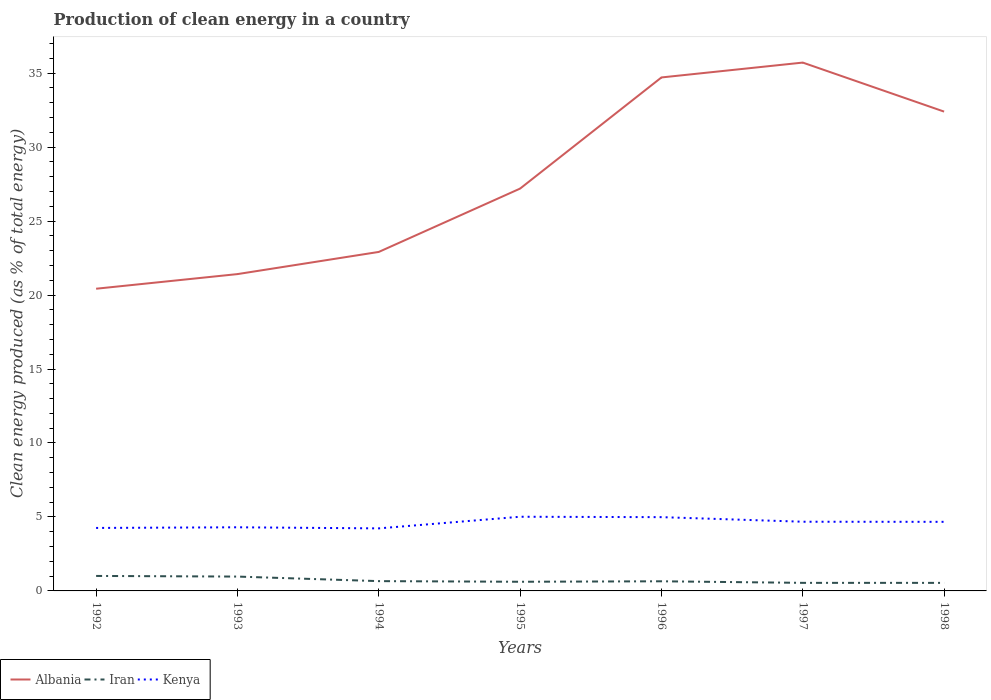Across all years, what is the maximum percentage of clean energy produced in Kenya?
Provide a succinct answer. 4.23. In which year was the percentage of clean energy produced in Iran maximum?
Offer a terse response. 1998. What is the total percentage of clean energy produced in Albania in the graph?
Your answer should be compact. -14.28. What is the difference between the highest and the second highest percentage of clean energy produced in Albania?
Provide a succinct answer. 15.29. What is the difference between the highest and the lowest percentage of clean energy produced in Kenya?
Keep it short and to the point. 4. Is the percentage of clean energy produced in Kenya strictly greater than the percentage of clean energy produced in Iran over the years?
Your response must be concise. No. How many lines are there?
Ensure brevity in your answer.  3. How many years are there in the graph?
Your answer should be very brief. 7. Does the graph contain grids?
Provide a succinct answer. No. How many legend labels are there?
Ensure brevity in your answer.  3. How are the legend labels stacked?
Your answer should be very brief. Horizontal. What is the title of the graph?
Provide a short and direct response. Production of clean energy in a country. What is the label or title of the Y-axis?
Give a very brief answer. Clean energy produced (as % of total energy). What is the Clean energy produced (as % of total energy) in Albania in 1992?
Provide a short and direct response. 20.43. What is the Clean energy produced (as % of total energy) of Iran in 1992?
Ensure brevity in your answer.  1.01. What is the Clean energy produced (as % of total energy) of Kenya in 1992?
Make the answer very short. 4.26. What is the Clean energy produced (as % of total energy) of Albania in 1993?
Your answer should be very brief. 21.41. What is the Clean energy produced (as % of total energy) in Iran in 1993?
Your answer should be very brief. 0.97. What is the Clean energy produced (as % of total energy) of Kenya in 1993?
Ensure brevity in your answer.  4.3. What is the Clean energy produced (as % of total energy) of Albania in 1994?
Your answer should be compact. 22.91. What is the Clean energy produced (as % of total energy) in Iran in 1994?
Your answer should be compact. 0.66. What is the Clean energy produced (as % of total energy) in Kenya in 1994?
Your response must be concise. 4.23. What is the Clean energy produced (as % of total energy) in Albania in 1995?
Give a very brief answer. 27.2. What is the Clean energy produced (as % of total energy) in Iran in 1995?
Ensure brevity in your answer.  0.62. What is the Clean energy produced (as % of total energy) in Kenya in 1995?
Offer a terse response. 5.01. What is the Clean energy produced (as % of total energy) of Albania in 1996?
Your answer should be compact. 34.71. What is the Clean energy produced (as % of total energy) in Iran in 1996?
Make the answer very short. 0.65. What is the Clean energy produced (as % of total energy) in Kenya in 1996?
Ensure brevity in your answer.  4.99. What is the Clean energy produced (as % of total energy) of Albania in 1997?
Give a very brief answer. 35.71. What is the Clean energy produced (as % of total energy) of Iran in 1997?
Offer a very short reply. 0.55. What is the Clean energy produced (as % of total energy) of Kenya in 1997?
Offer a terse response. 4.68. What is the Clean energy produced (as % of total energy) of Albania in 1998?
Ensure brevity in your answer.  32.4. What is the Clean energy produced (as % of total energy) of Iran in 1998?
Keep it short and to the point. 0.54. What is the Clean energy produced (as % of total energy) in Kenya in 1998?
Ensure brevity in your answer.  4.67. Across all years, what is the maximum Clean energy produced (as % of total energy) in Albania?
Ensure brevity in your answer.  35.71. Across all years, what is the maximum Clean energy produced (as % of total energy) of Iran?
Give a very brief answer. 1.01. Across all years, what is the maximum Clean energy produced (as % of total energy) of Kenya?
Your answer should be compact. 5.01. Across all years, what is the minimum Clean energy produced (as % of total energy) of Albania?
Make the answer very short. 20.43. Across all years, what is the minimum Clean energy produced (as % of total energy) of Iran?
Offer a terse response. 0.54. Across all years, what is the minimum Clean energy produced (as % of total energy) of Kenya?
Make the answer very short. 4.23. What is the total Clean energy produced (as % of total energy) in Albania in the graph?
Your answer should be compact. 194.77. What is the total Clean energy produced (as % of total energy) in Iran in the graph?
Give a very brief answer. 5. What is the total Clean energy produced (as % of total energy) in Kenya in the graph?
Ensure brevity in your answer.  32.13. What is the difference between the Clean energy produced (as % of total energy) in Albania in 1992 and that in 1993?
Provide a short and direct response. -0.99. What is the difference between the Clean energy produced (as % of total energy) of Iran in 1992 and that in 1993?
Provide a short and direct response. 0.04. What is the difference between the Clean energy produced (as % of total energy) of Kenya in 1992 and that in 1993?
Provide a succinct answer. -0.04. What is the difference between the Clean energy produced (as % of total energy) in Albania in 1992 and that in 1994?
Your answer should be compact. -2.49. What is the difference between the Clean energy produced (as % of total energy) in Iran in 1992 and that in 1994?
Ensure brevity in your answer.  0.35. What is the difference between the Clean energy produced (as % of total energy) of Kenya in 1992 and that in 1994?
Provide a short and direct response. 0.03. What is the difference between the Clean energy produced (as % of total energy) of Albania in 1992 and that in 1995?
Your answer should be very brief. -6.77. What is the difference between the Clean energy produced (as % of total energy) of Iran in 1992 and that in 1995?
Your response must be concise. 0.39. What is the difference between the Clean energy produced (as % of total energy) in Kenya in 1992 and that in 1995?
Provide a succinct answer. -0.76. What is the difference between the Clean energy produced (as % of total energy) of Albania in 1992 and that in 1996?
Provide a succinct answer. -14.28. What is the difference between the Clean energy produced (as % of total energy) of Iran in 1992 and that in 1996?
Ensure brevity in your answer.  0.36. What is the difference between the Clean energy produced (as % of total energy) of Kenya in 1992 and that in 1996?
Offer a very short reply. -0.73. What is the difference between the Clean energy produced (as % of total energy) of Albania in 1992 and that in 1997?
Offer a terse response. -15.29. What is the difference between the Clean energy produced (as % of total energy) in Iran in 1992 and that in 1997?
Ensure brevity in your answer.  0.47. What is the difference between the Clean energy produced (as % of total energy) of Kenya in 1992 and that in 1997?
Offer a very short reply. -0.42. What is the difference between the Clean energy produced (as % of total energy) of Albania in 1992 and that in 1998?
Offer a very short reply. -11.97. What is the difference between the Clean energy produced (as % of total energy) of Iran in 1992 and that in 1998?
Provide a short and direct response. 0.47. What is the difference between the Clean energy produced (as % of total energy) in Kenya in 1992 and that in 1998?
Give a very brief answer. -0.41. What is the difference between the Clean energy produced (as % of total energy) in Albania in 1993 and that in 1994?
Keep it short and to the point. -1.5. What is the difference between the Clean energy produced (as % of total energy) of Iran in 1993 and that in 1994?
Give a very brief answer. 0.31. What is the difference between the Clean energy produced (as % of total energy) in Kenya in 1993 and that in 1994?
Your answer should be very brief. 0.07. What is the difference between the Clean energy produced (as % of total energy) of Albania in 1993 and that in 1995?
Provide a succinct answer. -5.78. What is the difference between the Clean energy produced (as % of total energy) in Iran in 1993 and that in 1995?
Provide a short and direct response. 0.35. What is the difference between the Clean energy produced (as % of total energy) in Kenya in 1993 and that in 1995?
Provide a short and direct response. -0.71. What is the difference between the Clean energy produced (as % of total energy) in Albania in 1993 and that in 1996?
Your response must be concise. -13.29. What is the difference between the Clean energy produced (as % of total energy) of Iran in 1993 and that in 1996?
Offer a very short reply. 0.32. What is the difference between the Clean energy produced (as % of total energy) in Kenya in 1993 and that in 1996?
Your answer should be very brief. -0.69. What is the difference between the Clean energy produced (as % of total energy) of Albania in 1993 and that in 1997?
Offer a terse response. -14.3. What is the difference between the Clean energy produced (as % of total energy) of Iran in 1993 and that in 1997?
Offer a very short reply. 0.42. What is the difference between the Clean energy produced (as % of total energy) in Kenya in 1993 and that in 1997?
Provide a succinct answer. -0.38. What is the difference between the Clean energy produced (as % of total energy) in Albania in 1993 and that in 1998?
Provide a succinct answer. -10.98. What is the difference between the Clean energy produced (as % of total energy) of Iran in 1993 and that in 1998?
Offer a very short reply. 0.43. What is the difference between the Clean energy produced (as % of total energy) in Kenya in 1993 and that in 1998?
Ensure brevity in your answer.  -0.37. What is the difference between the Clean energy produced (as % of total energy) of Albania in 1994 and that in 1995?
Your answer should be compact. -4.28. What is the difference between the Clean energy produced (as % of total energy) in Iran in 1994 and that in 1995?
Your answer should be very brief. 0.04. What is the difference between the Clean energy produced (as % of total energy) in Kenya in 1994 and that in 1995?
Make the answer very short. -0.79. What is the difference between the Clean energy produced (as % of total energy) in Albania in 1994 and that in 1996?
Provide a succinct answer. -11.79. What is the difference between the Clean energy produced (as % of total energy) of Iran in 1994 and that in 1996?
Provide a short and direct response. 0.01. What is the difference between the Clean energy produced (as % of total energy) of Kenya in 1994 and that in 1996?
Offer a very short reply. -0.76. What is the difference between the Clean energy produced (as % of total energy) in Albania in 1994 and that in 1997?
Provide a short and direct response. -12.8. What is the difference between the Clean energy produced (as % of total energy) in Iran in 1994 and that in 1997?
Provide a short and direct response. 0.12. What is the difference between the Clean energy produced (as % of total energy) in Kenya in 1994 and that in 1997?
Offer a terse response. -0.45. What is the difference between the Clean energy produced (as % of total energy) of Albania in 1994 and that in 1998?
Offer a terse response. -9.49. What is the difference between the Clean energy produced (as % of total energy) of Iran in 1994 and that in 1998?
Your answer should be very brief. 0.12. What is the difference between the Clean energy produced (as % of total energy) in Kenya in 1994 and that in 1998?
Your answer should be compact. -0.44. What is the difference between the Clean energy produced (as % of total energy) in Albania in 1995 and that in 1996?
Your answer should be very brief. -7.51. What is the difference between the Clean energy produced (as % of total energy) of Iran in 1995 and that in 1996?
Offer a very short reply. -0.03. What is the difference between the Clean energy produced (as % of total energy) of Kenya in 1995 and that in 1996?
Provide a short and direct response. 0.03. What is the difference between the Clean energy produced (as % of total energy) of Albania in 1995 and that in 1997?
Keep it short and to the point. -8.52. What is the difference between the Clean energy produced (as % of total energy) of Iran in 1995 and that in 1997?
Offer a very short reply. 0.07. What is the difference between the Clean energy produced (as % of total energy) of Kenya in 1995 and that in 1997?
Offer a terse response. 0.34. What is the difference between the Clean energy produced (as % of total energy) in Albania in 1995 and that in 1998?
Provide a short and direct response. -5.2. What is the difference between the Clean energy produced (as % of total energy) of Iran in 1995 and that in 1998?
Give a very brief answer. 0.07. What is the difference between the Clean energy produced (as % of total energy) of Kenya in 1995 and that in 1998?
Provide a succinct answer. 0.34. What is the difference between the Clean energy produced (as % of total energy) in Albania in 1996 and that in 1997?
Provide a succinct answer. -1. What is the difference between the Clean energy produced (as % of total energy) of Iran in 1996 and that in 1997?
Offer a very short reply. 0.11. What is the difference between the Clean energy produced (as % of total energy) of Kenya in 1996 and that in 1997?
Ensure brevity in your answer.  0.31. What is the difference between the Clean energy produced (as % of total energy) in Albania in 1996 and that in 1998?
Offer a terse response. 2.31. What is the difference between the Clean energy produced (as % of total energy) in Iran in 1996 and that in 1998?
Keep it short and to the point. 0.11. What is the difference between the Clean energy produced (as % of total energy) in Kenya in 1996 and that in 1998?
Provide a succinct answer. 0.32. What is the difference between the Clean energy produced (as % of total energy) of Albania in 1997 and that in 1998?
Your answer should be very brief. 3.31. What is the difference between the Clean energy produced (as % of total energy) in Iran in 1997 and that in 1998?
Make the answer very short. 0. What is the difference between the Clean energy produced (as % of total energy) in Kenya in 1997 and that in 1998?
Your answer should be compact. 0.01. What is the difference between the Clean energy produced (as % of total energy) of Albania in 1992 and the Clean energy produced (as % of total energy) of Iran in 1993?
Your answer should be very brief. 19.46. What is the difference between the Clean energy produced (as % of total energy) in Albania in 1992 and the Clean energy produced (as % of total energy) in Kenya in 1993?
Offer a terse response. 16.13. What is the difference between the Clean energy produced (as % of total energy) in Iran in 1992 and the Clean energy produced (as % of total energy) in Kenya in 1993?
Provide a short and direct response. -3.29. What is the difference between the Clean energy produced (as % of total energy) in Albania in 1992 and the Clean energy produced (as % of total energy) in Iran in 1994?
Ensure brevity in your answer.  19.76. What is the difference between the Clean energy produced (as % of total energy) in Albania in 1992 and the Clean energy produced (as % of total energy) in Kenya in 1994?
Offer a terse response. 16.2. What is the difference between the Clean energy produced (as % of total energy) in Iran in 1992 and the Clean energy produced (as % of total energy) in Kenya in 1994?
Keep it short and to the point. -3.21. What is the difference between the Clean energy produced (as % of total energy) of Albania in 1992 and the Clean energy produced (as % of total energy) of Iran in 1995?
Ensure brevity in your answer.  19.81. What is the difference between the Clean energy produced (as % of total energy) of Albania in 1992 and the Clean energy produced (as % of total energy) of Kenya in 1995?
Your answer should be very brief. 15.41. What is the difference between the Clean energy produced (as % of total energy) of Iran in 1992 and the Clean energy produced (as % of total energy) of Kenya in 1995?
Offer a very short reply. -4. What is the difference between the Clean energy produced (as % of total energy) in Albania in 1992 and the Clean energy produced (as % of total energy) in Iran in 1996?
Give a very brief answer. 19.78. What is the difference between the Clean energy produced (as % of total energy) of Albania in 1992 and the Clean energy produced (as % of total energy) of Kenya in 1996?
Your answer should be very brief. 15.44. What is the difference between the Clean energy produced (as % of total energy) of Iran in 1992 and the Clean energy produced (as % of total energy) of Kenya in 1996?
Ensure brevity in your answer.  -3.97. What is the difference between the Clean energy produced (as % of total energy) in Albania in 1992 and the Clean energy produced (as % of total energy) in Iran in 1997?
Make the answer very short. 19.88. What is the difference between the Clean energy produced (as % of total energy) in Albania in 1992 and the Clean energy produced (as % of total energy) in Kenya in 1997?
Offer a terse response. 15.75. What is the difference between the Clean energy produced (as % of total energy) of Iran in 1992 and the Clean energy produced (as % of total energy) of Kenya in 1997?
Your response must be concise. -3.66. What is the difference between the Clean energy produced (as % of total energy) in Albania in 1992 and the Clean energy produced (as % of total energy) in Iran in 1998?
Make the answer very short. 19.88. What is the difference between the Clean energy produced (as % of total energy) in Albania in 1992 and the Clean energy produced (as % of total energy) in Kenya in 1998?
Offer a terse response. 15.76. What is the difference between the Clean energy produced (as % of total energy) of Iran in 1992 and the Clean energy produced (as % of total energy) of Kenya in 1998?
Provide a succinct answer. -3.66. What is the difference between the Clean energy produced (as % of total energy) in Albania in 1993 and the Clean energy produced (as % of total energy) in Iran in 1994?
Provide a succinct answer. 20.75. What is the difference between the Clean energy produced (as % of total energy) in Albania in 1993 and the Clean energy produced (as % of total energy) in Kenya in 1994?
Ensure brevity in your answer.  17.19. What is the difference between the Clean energy produced (as % of total energy) of Iran in 1993 and the Clean energy produced (as % of total energy) of Kenya in 1994?
Offer a terse response. -3.26. What is the difference between the Clean energy produced (as % of total energy) in Albania in 1993 and the Clean energy produced (as % of total energy) in Iran in 1995?
Give a very brief answer. 20.8. What is the difference between the Clean energy produced (as % of total energy) of Albania in 1993 and the Clean energy produced (as % of total energy) of Kenya in 1995?
Offer a terse response. 16.4. What is the difference between the Clean energy produced (as % of total energy) in Iran in 1993 and the Clean energy produced (as % of total energy) in Kenya in 1995?
Make the answer very short. -4.04. What is the difference between the Clean energy produced (as % of total energy) of Albania in 1993 and the Clean energy produced (as % of total energy) of Iran in 1996?
Make the answer very short. 20.76. What is the difference between the Clean energy produced (as % of total energy) of Albania in 1993 and the Clean energy produced (as % of total energy) of Kenya in 1996?
Provide a short and direct response. 16.43. What is the difference between the Clean energy produced (as % of total energy) in Iran in 1993 and the Clean energy produced (as % of total energy) in Kenya in 1996?
Provide a short and direct response. -4.02. What is the difference between the Clean energy produced (as % of total energy) of Albania in 1993 and the Clean energy produced (as % of total energy) of Iran in 1997?
Make the answer very short. 20.87. What is the difference between the Clean energy produced (as % of total energy) of Albania in 1993 and the Clean energy produced (as % of total energy) of Kenya in 1997?
Offer a terse response. 16.74. What is the difference between the Clean energy produced (as % of total energy) in Iran in 1993 and the Clean energy produced (as % of total energy) in Kenya in 1997?
Make the answer very short. -3.71. What is the difference between the Clean energy produced (as % of total energy) of Albania in 1993 and the Clean energy produced (as % of total energy) of Iran in 1998?
Your answer should be compact. 20.87. What is the difference between the Clean energy produced (as % of total energy) in Albania in 1993 and the Clean energy produced (as % of total energy) in Kenya in 1998?
Your answer should be compact. 16.75. What is the difference between the Clean energy produced (as % of total energy) in Iran in 1993 and the Clean energy produced (as % of total energy) in Kenya in 1998?
Give a very brief answer. -3.7. What is the difference between the Clean energy produced (as % of total energy) of Albania in 1994 and the Clean energy produced (as % of total energy) of Iran in 1995?
Offer a terse response. 22.29. What is the difference between the Clean energy produced (as % of total energy) of Albania in 1994 and the Clean energy produced (as % of total energy) of Kenya in 1995?
Offer a terse response. 17.9. What is the difference between the Clean energy produced (as % of total energy) in Iran in 1994 and the Clean energy produced (as % of total energy) in Kenya in 1995?
Offer a terse response. -4.35. What is the difference between the Clean energy produced (as % of total energy) of Albania in 1994 and the Clean energy produced (as % of total energy) of Iran in 1996?
Give a very brief answer. 22.26. What is the difference between the Clean energy produced (as % of total energy) in Albania in 1994 and the Clean energy produced (as % of total energy) in Kenya in 1996?
Your response must be concise. 17.93. What is the difference between the Clean energy produced (as % of total energy) of Iran in 1994 and the Clean energy produced (as % of total energy) of Kenya in 1996?
Offer a terse response. -4.32. What is the difference between the Clean energy produced (as % of total energy) of Albania in 1994 and the Clean energy produced (as % of total energy) of Iran in 1997?
Ensure brevity in your answer.  22.37. What is the difference between the Clean energy produced (as % of total energy) of Albania in 1994 and the Clean energy produced (as % of total energy) of Kenya in 1997?
Your answer should be very brief. 18.24. What is the difference between the Clean energy produced (as % of total energy) in Iran in 1994 and the Clean energy produced (as % of total energy) in Kenya in 1997?
Your response must be concise. -4.02. What is the difference between the Clean energy produced (as % of total energy) of Albania in 1994 and the Clean energy produced (as % of total energy) of Iran in 1998?
Keep it short and to the point. 22.37. What is the difference between the Clean energy produced (as % of total energy) of Albania in 1994 and the Clean energy produced (as % of total energy) of Kenya in 1998?
Your answer should be very brief. 18.24. What is the difference between the Clean energy produced (as % of total energy) of Iran in 1994 and the Clean energy produced (as % of total energy) of Kenya in 1998?
Give a very brief answer. -4.01. What is the difference between the Clean energy produced (as % of total energy) in Albania in 1995 and the Clean energy produced (as % of total energy) in Iran in 1996?
Offer a very short reply. 26.54. What is the difference between the Clean energy produced (as % of total energy) in Albania in 1995 and the Clean energy produced (as % of total energy) in Kenya in 1996?
Offer a very short reply. 22.21. What is the difference between the Clean energy produced (as % of total energy) of Iran in 1995 and the Clean energy produced (as % of total energy) of Kenya in 1996?
Your answer should be very brief. -4.37. What is the difference between the Clean energy produced (as % of total energy) in Albania in 1995 and the Clean energy produced (as % of total energy) in Iran in 1997?
Offer a very short reply. 26.65. What is the difference between the Clean energy produced (as % of total energy) in Albania in 1995 and the Clean energy produced (as % of total energy) in Kenya in 1997?
Provide a succinct answer. 22.52. What is the difference between the Clean energy produced (as % of total energy) in Iran in 1995 and the Clean energy produced (as % of total energy) in Kenya in 1997?
Your answer should be compact. -4.06. What is the difference between the Clean energy produced (as % of total energy) in Albania in 1995 and the Clean energy produced (as % of total energy) in Iran in 1998?
Your response must be concise. 26.65. What is the difference between the Clean energy produced (as % of total energy) in Albania in 1995 and the Clean energy produced (as % of total energy) in Kenya in 1998?
Give a very brief answer. 22.53. What is the difference between the Clean energy produced (as % of total energy) in Iran in 1995 and the Clean energy produced (as % of total energy) in Kenya in 1998?
Offer a very short reply. -4.05. What is the difference between the Clean energy produced (as % of total energy) in Albania in 1996 and the Clean energy produced (as % of total energy) in Iran in 1997?
Offer a terse response. 34.16. What is the difference between the Clean energy produced (as % of total energy) in Albania in 1996 and the Clean energy produced (as % of total energy) in Kenya in 1997?
Ensure brevity in your answer.  30.03. What is the difference between the Clean energy produced (as % of total energy) in Iran in 1996 and the Clean energy produced (as % of total energy) in Kenya in 1997?
Provide a short and direct response. -4.03. What is the difference between the Clean energy produced (as % of total energy) in Albania in 1996 and the Clean energy produced (as % of total energy) in Iran in 1998?
Your response must be concise. 34.16. What is the difference between the Clean energy produced (as % of total energy) in Albania in 1996 and the Clean energy produced (as % of total energy) in Kenya in 1998?
Your answer should be compact. 30.04. What is the difference between the Clean energy produced (as % of total energy) in Iran in 1996 and the Clean energy produced (as % of total energy) in Kenya in 1998?
Offer a very short reply. -4.02. What is the difference between the Clean energy produced (as % of total energy) in Albania in 1997 and the Clean energy produced (as % of total energy) in Iran in 1998?
Offer a terse response. 35.17. What is the difference between the Clean energy produced (as % of total energy) in Albania in 1997 and the Clean energy produced (as % of total energy) in Kenya in 1998?
Your response must be concise. 31.04. What is the difference between the Clean energy produced (as % of total energy) in Iran in 1997 and the Clean energy produced (as % of total energy) in Kenya in 1998?
Offer a very short reply. -4.12. What is the average Clean energy produced (as % of total energy) of Albania per year?
Your answer should be very brief. 27.82. What is the average Clean energy produced (as % of total energy) in Iran per year?
Your answer should be compact. 0.71. What is the average Clean energy produced (as % of total energy) of Kenya per year?
Your response must be concise. 4.59. In the year 1992, what is the difference between the Clean energy produced (as % of total energy) of Albania and Clean energy produced (as % of total energy) of Iran?
Your answer should be compact. 19.41. In the year 1992, what is the difference between the Clean energy produced (as % of total energy) in Albania and Clean energy produced (as % of total energy) in Kenya?
Your answer should be very brief. 16.17. In the year 1992, what is the difference between the Clean energy produced (as % of total energy) of Iran and Clean energy produced (as % of total energy) of Kenya?
Keep it short and to the point. -3.24. In the year 1993, what is the difference between the Clean energy produced (as % of total energy) of Albania and Clean energy produced (as % of total energy) of Iran?
Make the answer very short. 20.45. In the year 1993, what is the difference between the Clean energy produced (as % of total energy) in Albania and Clean energy produced (as % of total energy) in Kenya?
Your answer should be very brief. 17.11. In the year 1993, what is the difference between the Clean energy produced (as % of total energy) in Iran and Clean energy produced (as % of total energy) in Kenya?
Offer a very short reply. -3.33. In the year 1994, what is the difference between the Clean energy produced (as % of total energy) in Albania and Clean energy produced (as % of total energy) in Iran?
Offer a terse response. 22.25. In the year 1994, what is the difference between the Clean energy produced (as % of total energy) in Albania and Clean energy produced (as % of total energy) in Kenya?
Ensure brevity in your answer.  18.69. In the year 1994, what is the difference between the Clean energy produced (as % of total energy) in Iran and Clean energy produced (as % of total energy) in Kenya?
Make the answer very short. -3.57. In the year 1995, what is the difference between the Clean energy produced (as % of total energy) of Albania and Clean energy produced (as % of total energy) of Iran?
Keep it short and to the point. 26.58. In the year 1995, what is the difference between the Clean energy produced (as % of total energy) in Albania and Clean energy produced (as % of total energy) in Kenya?
Provide a short and direct response. 22.18. In the year 1995, what is the difference between the Clean energy produced (as % of total energy) in Iran and Clean energy produced (as % of total energy) in Kenya?
Keep it short and to the point. -4.39. In the year 1996, what is the difference between the Clean energy produced (as % of total energy) in Albania and Clean energy produced (as % of total energy) in Iran?
Offer a terse response. 34.06. In the year 1996, what is the difference between the Clean energy produced (as % of total energy) of Albania and Clean energy produced (as % of total energy) of Kenya?
Your response must be concise. 29.72. In the year 1996, what is the difference between the Clean energy produced (as % of total energy) of Iran and Clean energy produced (as % of total energy) of Kenya?
Provide a short and direct response. -4.34. In the year 1997, what is the difference between the Clean energy produced (as % of total energy) in Albania and Clean energy produced (as % of total energy) in Iran?
Give a very brief answer. 35.17. In the year 1997, what is the difference between the Clean energy produced (as % of total energy) of Albania and Clean energy produced (as % of total energy) of Kenya?
Provide a short and direct response. 31.04. In the year 1997, what is the difference between the Clean energy produced (as % of total energy) in Iran and Clean energy produced (as % of total energy) in Kenya?
Keep it short and to the point. -4.13. In the year 1998, what is the difference between the Clean energy produced (as % of total energy) of Albania and Clean energy produced (as % of total energy) of Iran?
Offer a very short reply. 31.85. In the year 1998, what is the difference between the Clean energy produced (as % of total energy) of Albania and Clean energy produced (as % of total energy) of Kenya?
Offer a terse response. 27.73. In the year 1998, what is the difference between the Clean energy produced (as % of total energy) in Iran and Clean energy produced (as % of total energy) in Kenya?
Make the answer very short. -4.13. What is the ratio of the Clean energy produced (as % of total energy) in Albania in 1992 to that in 1993?
Your answer should be very brief. 0.95. What is the ratio of the Clean energy produced (as % of total energy) of Iran in 1992 to that in 1993?
Give a very brief answer. 1.04. What is the ratio of the Clean energy produced (as % of total energy) in Kenya in 1992 to that in 1993?
Make the answer very short. 0.99. What is the ratio of the Clean energy produced (as % of total energy) in Albania in 1992 to that in 1994?
Offer a very short reply. 0.89. What is the ratio of the Clean energy produced (as % of total energy) in Iran in 1992 to that in 1994?
Keep it short and to the point. 1.53. What is the ratio of the Clean energy produced (as % of total energy) of Kenya in 1992 to that in 1994?
Make the answer very short. 1.01. What is the ratio of the Clean energy produced (as % of total energy) of Albania in 1992 to that in 1995?
Provide a short and direct response. 0.75. What is the ratio of the Clean energy produced (as % of total energy) of Iran in 1992 to that in 1995?
Your response must be concise. 1.64. What is the ratio of the Clean energy produced (as % of total energy) of Kenya in 1992 to that in 1995?
Give a very brief answer. 0.85. What is the ratio of the Clean energy produced (as % of total energy) in Albania in 1992 to that in 1996?
Your answer should be very brief. 0.59. What is the ratio of the Clean energy produced (as % of total energy) in Iran in 1992 to that in 1996?
Ensure brevity in your answer.  1.56. What is the ratio of the Clean energy produced (as % of total energy) in Kenya in 1992 to that in 1996?
Your answer should be very brief. 0.85. What is the ratio of the Clean energy produced (as % of total energy) in Albania in 1992 to that in 1997?
Provide a short and direct response. 0.57. What is the ratio of the Clean energy produced (as % of total energy) in Iran in 1992 to that in 1997?
Ensure brevity in your answer.  1.86. What is the ratio of the Clean energy produced (as % of total energy) of Kenya in 1992 to that in 1997?
Keep it short and to the point. 0.91. What is the ratio of the Clean energy produced (as % of total energy) in Albania in 1992 to that in 1998?
Ensure brevity in your answer.  0.63. What is the ratio of the Clean energy produced (as % of total energy) of Iran in 1992 to that in 1998?
Give a very brief answer. 1.86. What is the ratio of the Clean energy produced (as % of total energy) in Kenya in 1992 to that in 1998?
Offer a very short reply. 0.91. What is the ratio of the Clean energy produced (as % of total energy) in Albania in 1993 to that in 1994?
Provide a succinct answer. 0.93. What is the ratio of the Clean energy produced (as % of total energy) in Iran in 1993 to that in 1994?
Your response must be concise. 1.46. What is the ratio of the Clean energy produced (as % of total energy) of Kenya in 1993 to that in 1994?
Make the answer very short. 1.02. What is the ratio of the Clean energy produced (as % of total energy) in Albania in 1993 to that in 1995?
Your answer should be compact. 0.79. What is the ratio of the Clean energy produced (as % of total energy) of Iran in 1993 to that in 1995?
Ensure brevity in your answer.  1.57. What is the ratio of the Clean energy produced (as % of total energy) in Kenya in 1993 to that in 1995?
Your response must be concise. 0.86. What is the ratio of the Clean energy produced (as % of total energy) of Albania in 1993 to that in 1996?
Offer a very short reply. 0.62. What is the ratio of the Clean energy produced (as % of total energy) of Iran in 1993 to that in 1996?
Provide a short and direct response. 1.49. What is the ratio of the Clean energy produced (as % of total energy) of Kenya in 1993 to that in 1996?
Give a very brief answer. 0.86. What is the ratio of the Clean energy produced (as % of total energy) of Albania in 1993 to that in 1997?
Provide a short and direct response. 0.6. What is the ratio of the Clean energy produced (as % of total energy) of Iran in 1993 to that in 1997?
Ensure brevity in your answer.  1.78. What is the ratio of the Clean energy produced (as % of total energy) in Kenya in 1993 to that in 1997?
Make the answer very short. 0.92. What is the ratio of the Clean energy produced (as % of total energy) of Albania in 1993 to that in 1998?
Keep it short and to the point. 0.66. What is the ratio of the Clean energy produced (as % of total energy) of Iran in 1993 to that in 1998?
Your answer should be very brief. 1.78. What is the ratio of the Clean energy produced (as % of total energy) in Kenya in 1993 to that in 1998?
Your answer should be compact. 0.92. What is the ratio of the Clean energy produced (as % of total energy) in Albania in 1994 to that in 1995?
Provide a short and direct response. 0.84. What is the ratio of the Clean energy produced (as % of total energy) in Iran in 1994 to that in 1995?
Keep it short and to the point. 1.07. What is the ratio of the Clean energy produced (as % of total energy) of Kenya in 1994 to that in 1995?
Your response must be concise. 0.84. What is the ratio of the Clean energy produced (as % of total energy) in Albania in 1994 to that in 1996?
Provide a short and direct response. 0.66. What is the ratio of the Clean energy produced (as % of total energy) in Iran in 1994 to that in 1996?
Offer a terse response. 1.02. What is the ratio of the Clean energy produced (as % of total energy) in Kenya in 1994 to that in 1996?
Provide a succinct answer. 0.85. What is the ratio of the Clean energy produced (as % of total energy) in Albania in 1994 to that in 1997?
Your response must be concise. 0.64. What is the ratio of the Clean energy produced (as % of total energy) in Iran in 1994 to that in 1997?
Offer a very short reply. 1.21. What is the ratio of the Clean energy produced (as % of total energy) of Kenya in 1994 to that in 1997?
Your answer should be very brief. 0.9. What is the ratio of the Clean energy produced (as % of total energy) of Albania in 1994 to that in 1998?
Provide a succinct answer. 0.71. What is the ratio of the Clean energy produced (as % of total energy) in Iran in 1994 to that in 1998?
Offer a very short reply. 1.22. What is the ratio of the Clean energy produced (as % of total energy) in Kenya in 1994 to that in 1998?
Provide a short and direct response. 0.91. What is the ratio of the Clean energy produced (as % of total energy) in Albania in 1995 to that in 1996?
Ensure brevity in your answer.  0.78. What is the ratio of the Clean energy produced (as % of total energy) of Iran in 1995 to that in 1996?
Ensure brevity in your answer.  0.95. What is the ratio of the Clean energy produced (as % of total energy) in Kenya in 1995 to that in 1996?
Ensure brevity in your answer.  1.01. What is the ratio of the Clean energy produced (as % of total energy) of Albania in 1995 to that in 1997?
Offer a terse response. 0.76. What is the ratio of the Clean energy produced (as % of total energy) of Iran in 1995 to that in 1997?
Offer a very short reply. 1.14. What is the ratio of the Clean energy produced (as % of total energy) in Kenya in 1995 to that in 1997?
Your response must be concise. 1.07. What is the ratio of the Clean energy produced (as % of total energy) of Albania in 1995 to that in 1998?
Ensure brevity in your answer.  0.84. What is the ratio of the Clean energy produced (as % of total energy) of Iran in 1995 to that in 1998?
Your response must be concise. 1.14. What is the ratio of the Clean energy produced (as % of total energy) of Kenya in 1995 to that in 1998?
Provide a succinct answer. 1.07. What is the ratio of the Clean energy produced (as % of total energy) of Albania in 1996 to that in 1997?
Your answer should be very brief. 0.97. What is the ratio of the Clean energy produced (as % of total energy) in Iran in 1996 to that in 1997?
Provide a succinct answer. 1.19. What is the ratio of the Clean energy produced (as % of total energy) in Kenya in 1996 to that in 1997?
Make the answer very short. 1.07. What is the ratio of the Clean energy produced (as % of total energy) in Albania in 1996 to that in 1998?
Your answer should be compact. 1.07. What is the ratio of the Clean energy produced (as % of total energy) of Iran in 1996 to that in 1998?
Your answer should be compact. 1.2. What is the ratio of the Clean energy produced (as % of total energy) of Kenya in 1996 to that in 1998?
Give a very brief answer. 1.07. What is the ratio of the Clean energy produced (as % of total energy) in Albania in 1997 to that in 1998?
Your answer should be compact. 1.1. What is the ratio of the Clean energy produced (as % of total energy) of Kenya in 1997 to that in 1998?
Your response must be concise. 1. What is the difference between the highest and the second highest Clean energy produced (as % of total energy) of Albania?
Your answer should be very brief. 1. What is the difference between the highest and the second highest Clean energy produced (as % of total energy) in Iran?
Offer a very short reply. 0.04. What is the difference between the highest and the second highest Clean energy produced (as % of total energy) in Kenya?
Your response must be concise. 0.03. What is the difference between the highest and the lowest Clean energy produced (as % of total energy) in Albania?
Your answer should be compact. 15.29. What is the difference between the highest and the lowest Clean energy produced (as % of total energy) in Iran?
Provide a succinct answer. 0.47. What is the difference between the highest and the lowest Clean energy produced (as % of total energy) of Kenya?
Your answer should be very brief. 0.79. 